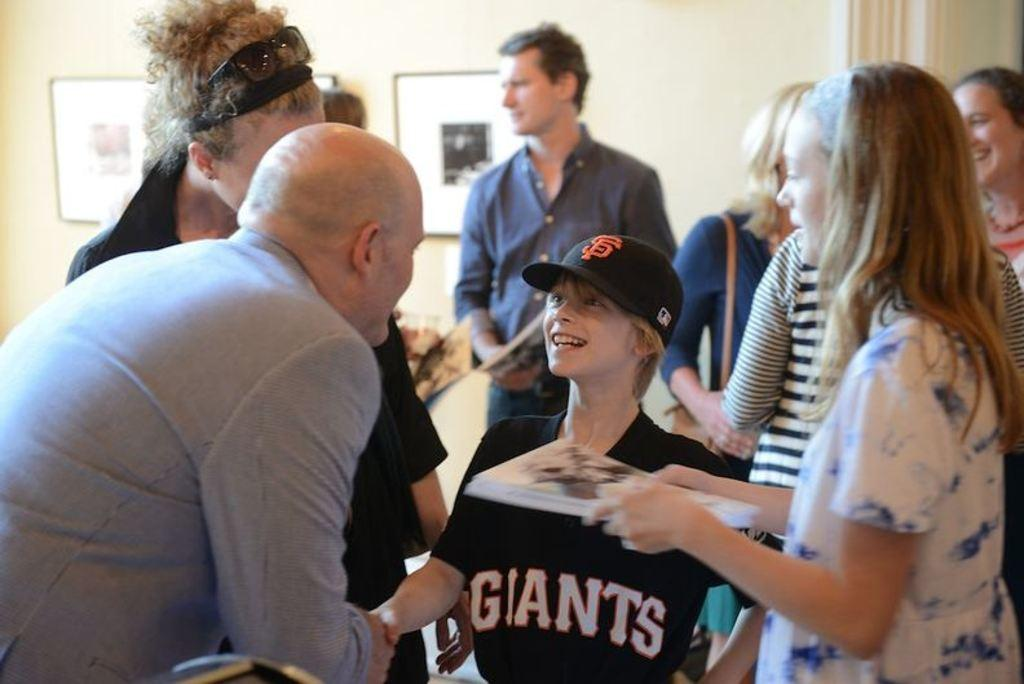How many people are in the image? There is a group of persons in the image. What are the persons in the image doing? The persons are standing on the floor. What can be seen in the background of the image? There are photo frames and a wall in the background of the image. What type of zephyr is blowing through the image? There is no zephyr present in the image. What disease is affecting the persons in the image? There is no indication of any disease affecting the persons in the image. 